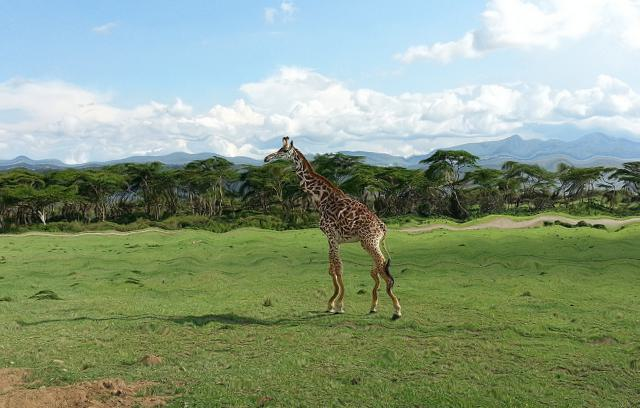Considering the surroundings, what time of day might it be, and why is that important for the giraffe? Judging by the shadows and lighting in the image, it may be late afternoon. For giraffes, the cooler parts of the day are opportune times for foraging as they spend the hottest hours resting in the shade, which helps in regulating their body temperature. 